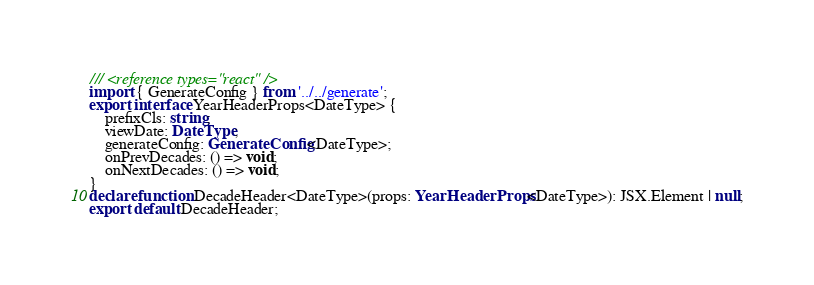Convert code to text. <code><loc_0><loc_0><loc_500><loc_500><_TypeScript_>/// <reference types="react" />
import { GenerateConfig } from '../../generate';
export interface YearHeaderProps<DateType> {
    prefixCls: string;
    viewDate: DateType;
    generateConfig: GenerateConfig<DateType>;
    onPrevDecades: () => void;
    onNextDecades: () => void;
}
declare function DecadeHeader<DateType>(props: YearHeaderProps<DateType>): JSX.Element | null;
export default DecadeHeader;
</code> 